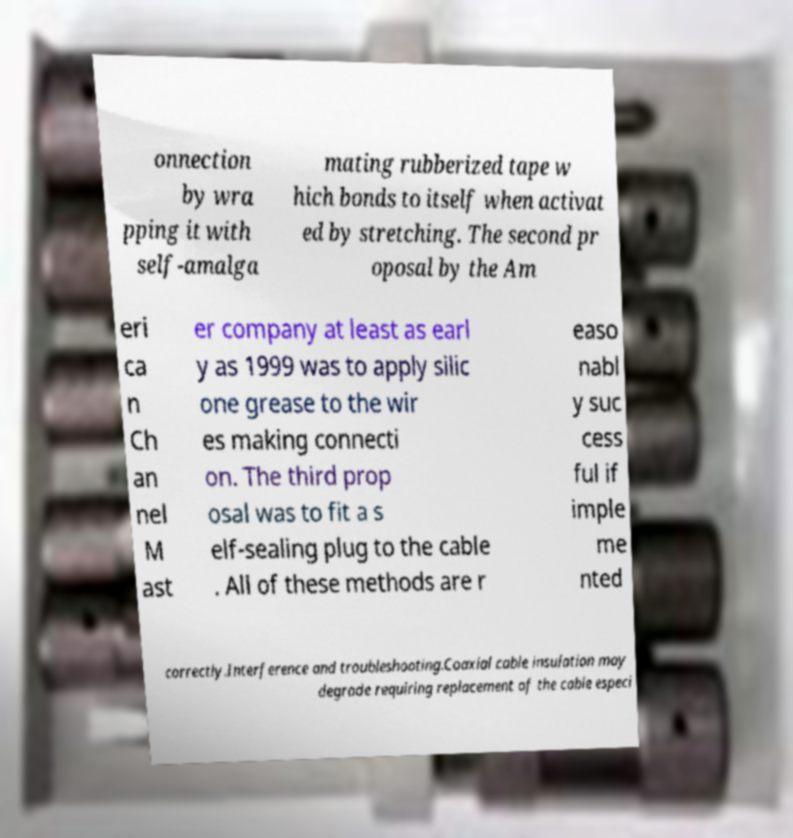Can you accurately transcribe the text from the provided image for me? onnection by wra pping it with self-amalga mating rubberized tape w hich bonds to itself when activat ed by stretching. The second pr oposal by the Am eri ca n Ch an nel M ast er company at least as earl y as 1999 was to apply silic one grease to the wir es making connecti on. The third prop osal was to fit a s elf-sealing plug to the cable . All of these methods are r easo nabl y suc cess ful if imple me nted correctly.Interference and troubleshooting.Coaxial cable insulation may degrade requiring replacement of the cable especi 